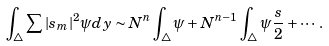<formula> <loc_0><loc_0><loc_500><loc_500>\int _ { \triangle } \sum | s _ { m } | ^ { 2 } \psi d y \sim N ^ { n } \int _ { \triangle } \psi + N ^ { n - 1 } \int _ { \triangle } \psi \frac { s } { 2 } + \cdots .</formula> 